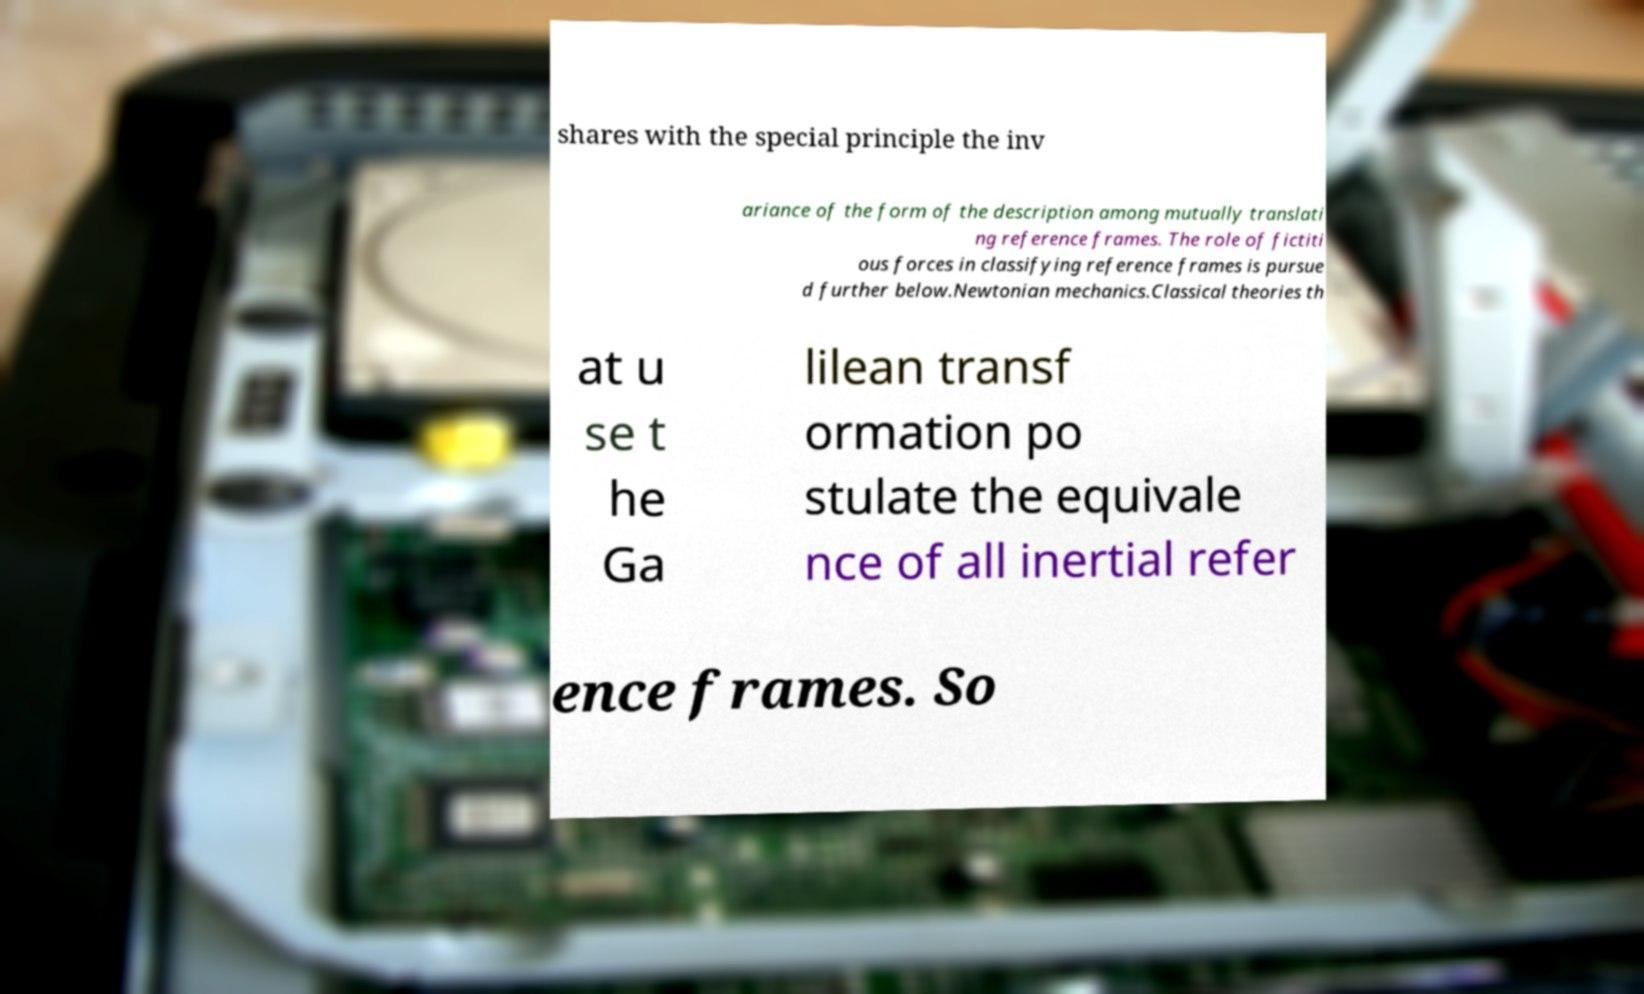There's text embedded in this image that I need extracted. Can you transcribe it verbatim? shares with the special principle the inv ariance of the form of the description among mutually translati ng reference frames. The role of fictiti ous forces in classifying reference frames is pursue d further below.Newtonian mechanics.Classical theories th at u se t he Ga lilean transf ormation po stulate the equivale nce of all inertial refer ence frames. So 